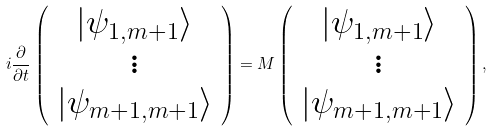<formula> <loc_0><loc_0><loc_500><loc_500>i \frac { \partial } { \partial t } \left ( \begin{array} { c c c c c } | \psi _ { 1 , m + 1 } \rangle \\ \vdots \\ | \psi _ { m + 1 , m + 1 } \rangle \end{array} \right ) = M \left ( \begin{array} { c c c c c } | \psi _ { 1 , m + 1 } \rangle \\ \vdots \\ | \psi _ { m + 1 , m + 1 } \rangle \end{array} \right ) ,</formula> 